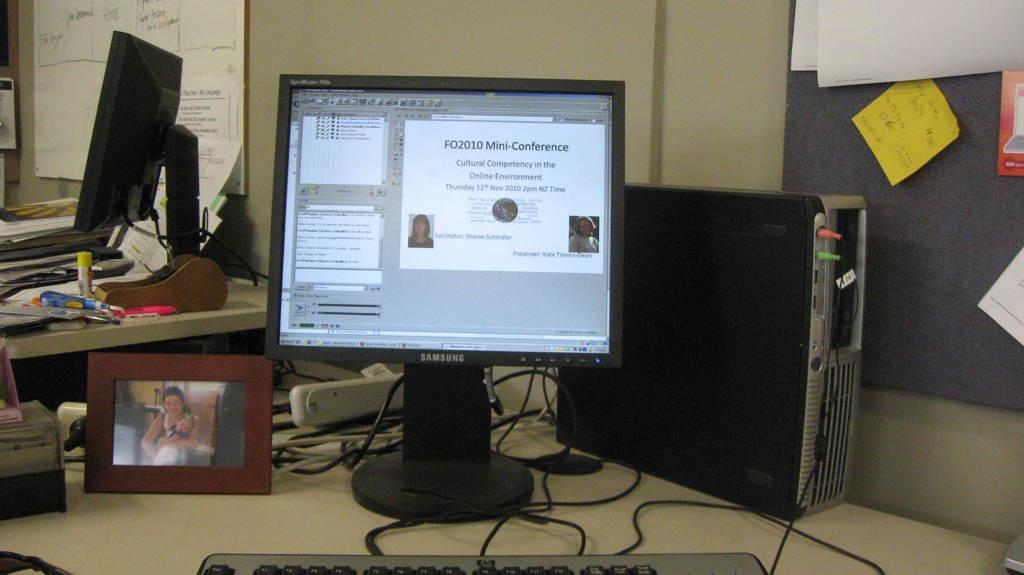<image>
Give a short and clear explanation of the subsequent image. Monitor sits on a table display a certificate for FO2010 Mini-Conference. 